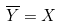<formula> <loc_0><loc_0><loc_500><loc_500>\overline { Y } = X</formula> 